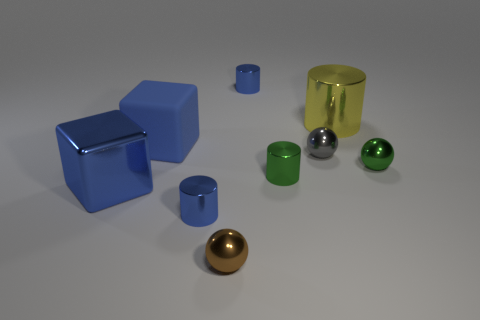There is a tiny thing that is left of the tiny brown metallic thing; what color is it?
Make the answer very short. Blue. Are the big cylinder and the tiny gray sphere made of the same material?
Make the answer very short. Yes. How many things are small objects or tiny cylinders that are in front of the big blue rubber object?
Make the answer very short. 6. What is the size of the rubber object that is the same color as the shiny cube?
Your answer should be very brief. Large. What is the shape of the large metallic object behind the tiny green ball?
Provide a short and direct response. Cylinder. There is a big object left of the blue matte object; is it the same color as the large rubber cube?
Provide a succinct answer. Yes. There is a large object that is the same color as the matte cube; what material is it?
Ensure brevity in your answer.  Metal. Does the cube that is in front of the green metal ball have the same size as the green ball?
Provide a short and direct response. No. Are there any other large objects that have the same color as the big matte thing?
Keep it short and to the point. Yes. Are there any tiny green things to the right of the blue cylinder in front of the big blue metal cube?
Offer a very short reply. Yes. 